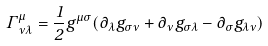<formula> <loc_0><loc_0><loc_500><loc_500>\Gamma _ { \nu \lambda } ^ { \mu } = \frac { 1 } { 2 } g ^ { \mu \sigma } ( \partial _ { \lambda } g _ { \sigma \nu } + \partial _ { \nu } g _ { \sigma \lambda } - \partial _ { \sigma } g _ { \lambda \nu } )</formula> 